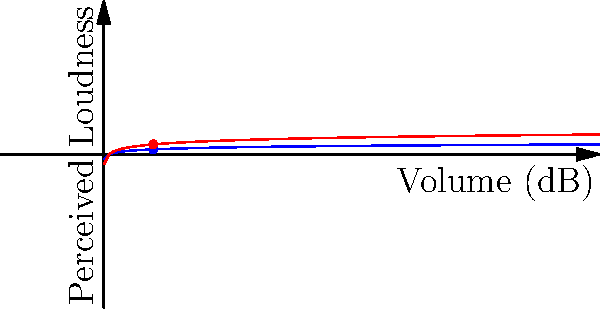The graph shows two curves representing the perceived loudness of music at different volumes. Curve A is given by the function $L = \log_{10}(V)$, where $L$ is the perceived loudness and $V$ is the volume in decibels. At a volume of 10 dB, what is the slope of Curve B, and how does it compare to the slope of Curve A at the same point? Let's approach this step-by-step:

1) Curve A is given by $L = \log_{10}(V)$
   Curve B appears to be $L = 2\log_{10}(V)$

2) To find the slope, we need to calculate the derivative of each function:
   For Curve A: $\frac{d}{dV}(\log_{10}(V)) = \frac{1}{V\ln(10)}$
   For Curve B: $\frac{d}{dV}(2\log_{10}(V)) = \frac{2}{V\ln(10)}$

3) At V = 10 dB:
   Slope of Curve A: $\frac{1}{10\ln(10)} \approx 0.0434$
   Slope of Curve B: $\frac{2}{10\ln(10)} \approx 0.0868$

4) The slope of Curve B is exactly twice the slope of Curve A at V = 10 dB.

This aligns with the graphic representation, where Curve B appears steeper than Curve A, indicating a more rapid increase in perceived loudness as volume increases.
Answer: $\frac{2}{10\ln(10)} \approx 0.0868$, twice the slope of Curve A 